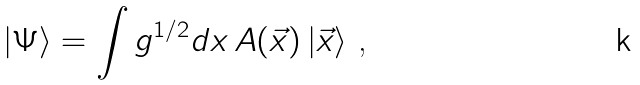<formula> <loc_0><loc_0><loc_500><loc_500>| \Psi \rangle = \int g ^ { 1 / 2 } d x \, A ( \vec { x } ) \, | \vec { x } \rangle \text { ,}</formula> 